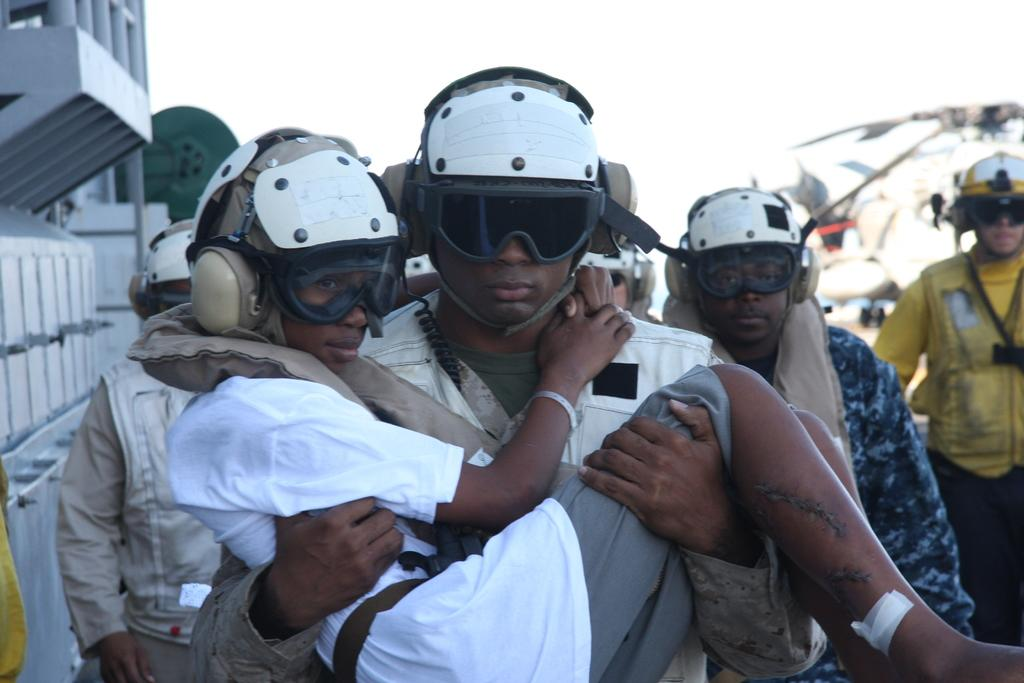What can be seen in the image? There is a group of men in the image. What are the men wearing? The men are wearing helmets and goggles. What is one man doing with a boy in the image? One man is carrying a boy with his hands. What can be seen in the background of the image? There are objects visible in the background of the image. What type of pleasure can be seen in the image? There is no indication of pleasure in the image; the focus is on the group of men and their attire and actions. --- Facts: 1. There is a car in the image. 2. The car is red. 3. The car has four wheels. 4. The car has a license plate. 5. The car is parked on the street. Absurd Topics: bird, ocean, mountain Conversation: What is the main subject of the image? The main subject of the image is a car. What color is the car? The car is red. How many wheels does the car have? The car has four wheels. Does the car have any identifying features? Yes, the car has a license plate. Where is the car located in the image? The car is parked on the street. Reasoning: Let's think step by step in order to produce the conversation. We start by identifying the main subject in the image, which is the car. Then, we describe the car's color, noting that it is red. Next, we mention the number of wheels the car has, which is four. We then acknowledge the presence of a license plate, which serves as an identifying feature. Finally, we describe the car's location, noting that it is parked on the street. Absurd Question/Answer: Can you see any birds, oceans, or mountains in the image? No, there are no birds, oceans, or mountains present in the image; the focus is on the red car parked on the street. 